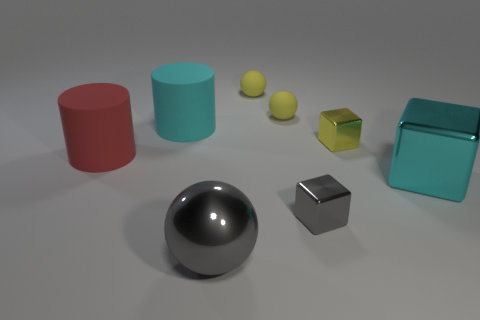Add 1 tiny yellow shiny things. How many objects exist? 9 Subtract all cylinders. How many objects are left? 6 Add 6 cyan metallic objects. How many cyan metallic objects exist? 7 Subtract 0 green cubes. How many objects are left? 8 Subtract all blue metal blocks. Subtract all large gray things. How many objects are left? 7 Add 7 small yellow shiny objects. How many small yellow shiny objects are left? 8 